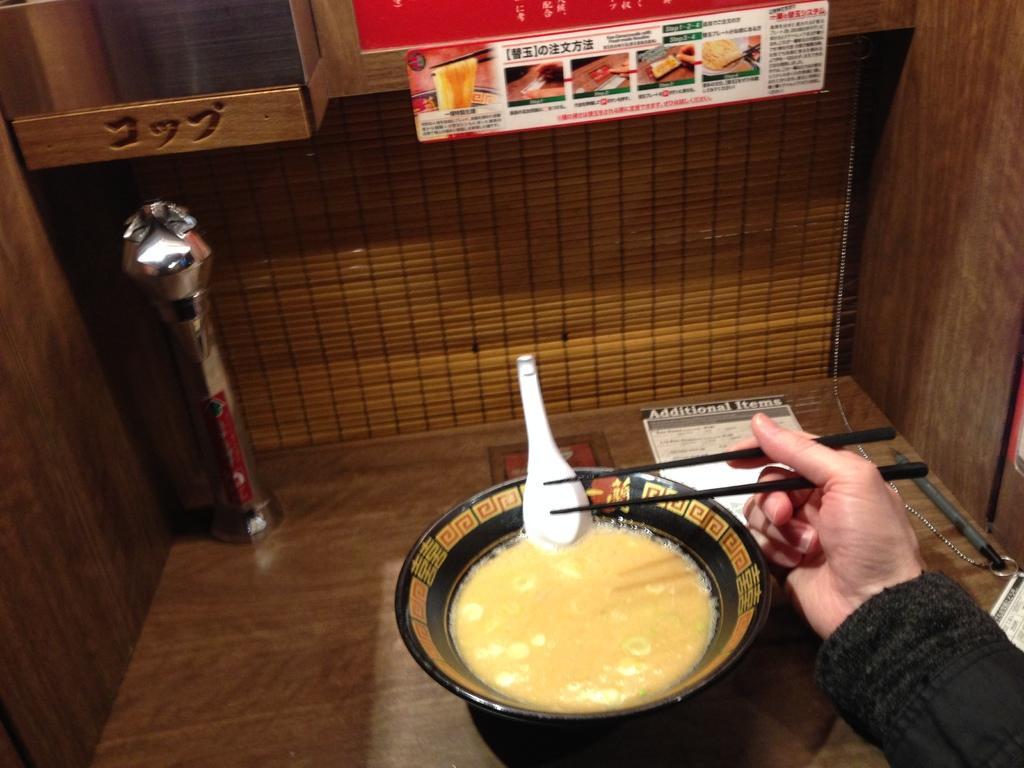In one or two sentences, can you explain what this image depicts? It looks like the image is clicked inside a room. The walls are made up of wood. In the front there is bowl in which food is kept and the man is eating it. In the background there is a poster. To the right person is wearing black colored dress. 